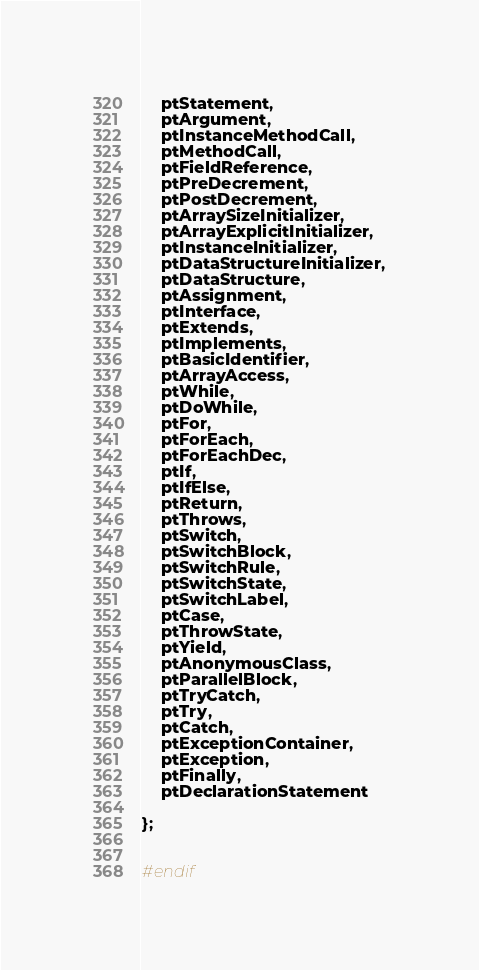Convert code to text. <code><loc_0><loc_0><loc_500><loc_500><_C_>	ptStatement,
	ptArgument,
	ptInstanceMethodCall,
	ptMethodCall,
	ptFieldReference,
	ptPreDecrement,
	ptPostDecrement,
	ptArraySizeInitializer,
	ptArrayExplicitInitializer,
	ptInstanceInitializer,
	ptDataStructureInitializer,
	ptDataStructure,
	ptAssignment,
	ptInterface,
	ptExtends,
	ptImplements,
	ptBasicIdentifier,
	ptArrayAccess,
	ptWhile,
	ptDoWhile,
	ptFor,
	ptForEach,
	ptForEachDec,
	ptIf,
	ptIfElse,
	ptReturn,
	ptThrows,
	ptSwitch,
	ptSwitchBlock,
	ptSwitchRule,
	ptSwitchState,
	ptSwitchLabel,	
	ptCase,
	ptThrowState,
	ptYield,
	ptAnonymousClass,
	ptParallelBlock,
	ptTryCatch,
	ptTry,
	ptCatch,
	ptExceptionContainer,
	ptException,
	ptFinally,
	ptDeclarationStatement

};


#endif






















</code> 